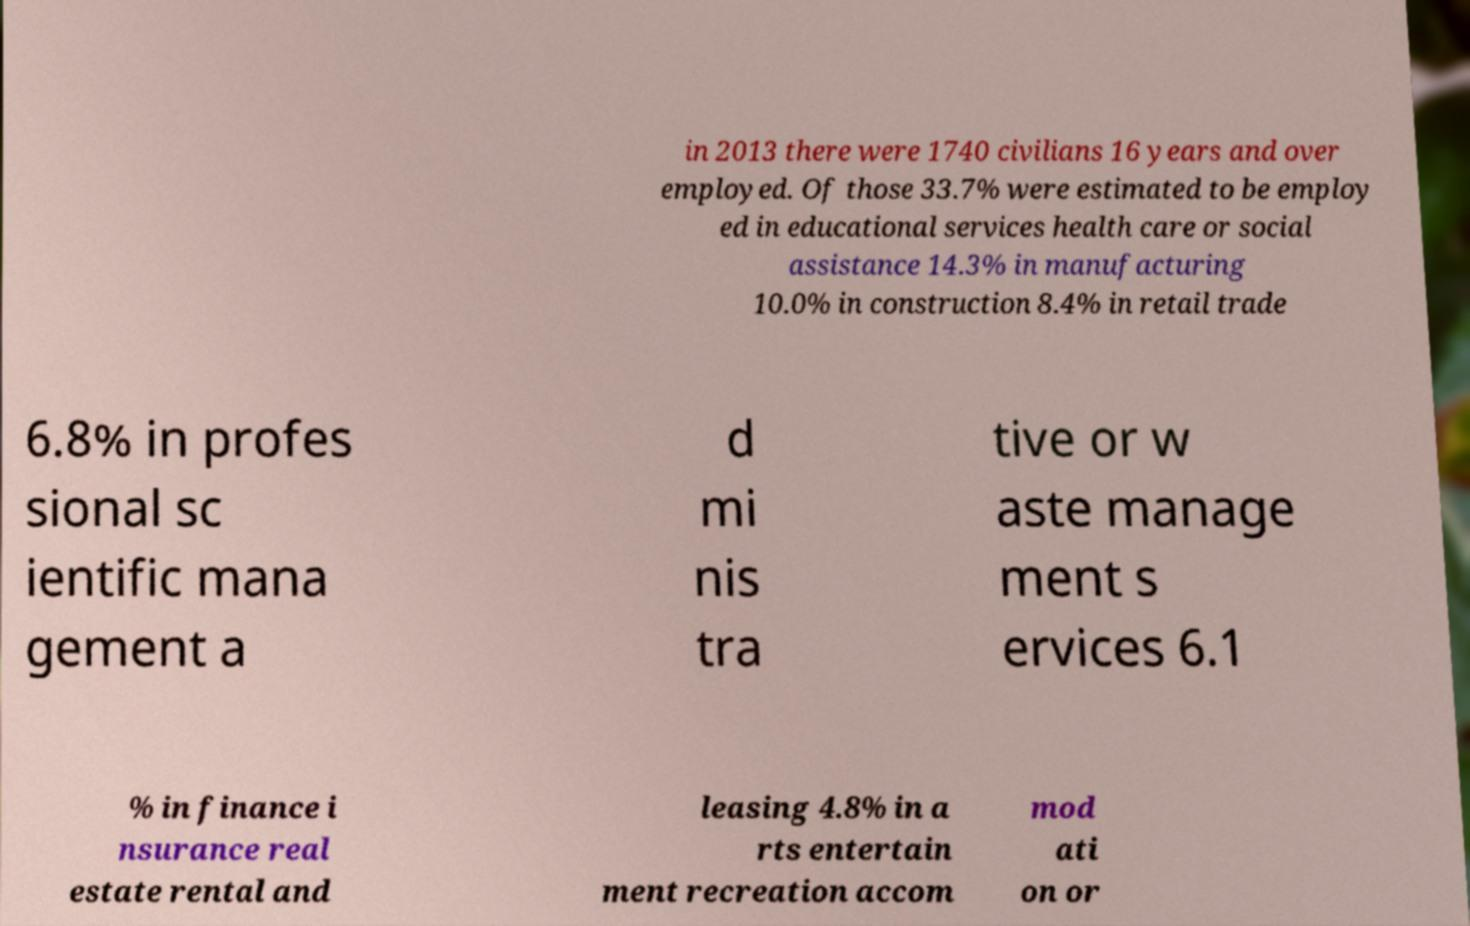There's text embedded in this image that I need extracted. Can you transcribe it verbatim? in 2013 there were 1740 civilians 16 years and over employed. Of those 33.7% were estimated to be employ ed in educational services health care or social assistance 14.3% in manufacturing 10.0% in construction 8.4% in retail trade 6.8% in profes sional sc ientific mana gement a d mi nis tra tive or w aste manage ment s ervices 6.1 % in finance i nsurance real estate rental and leasing 4.8% in a rts entertain ment recreation accom mod ati on or 